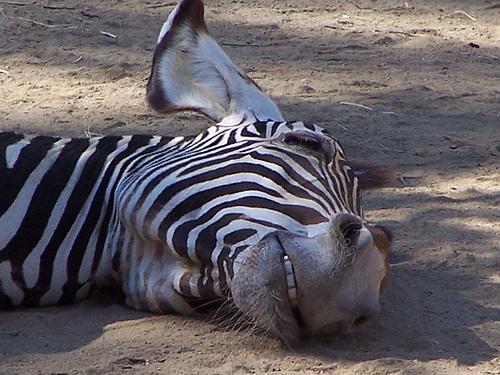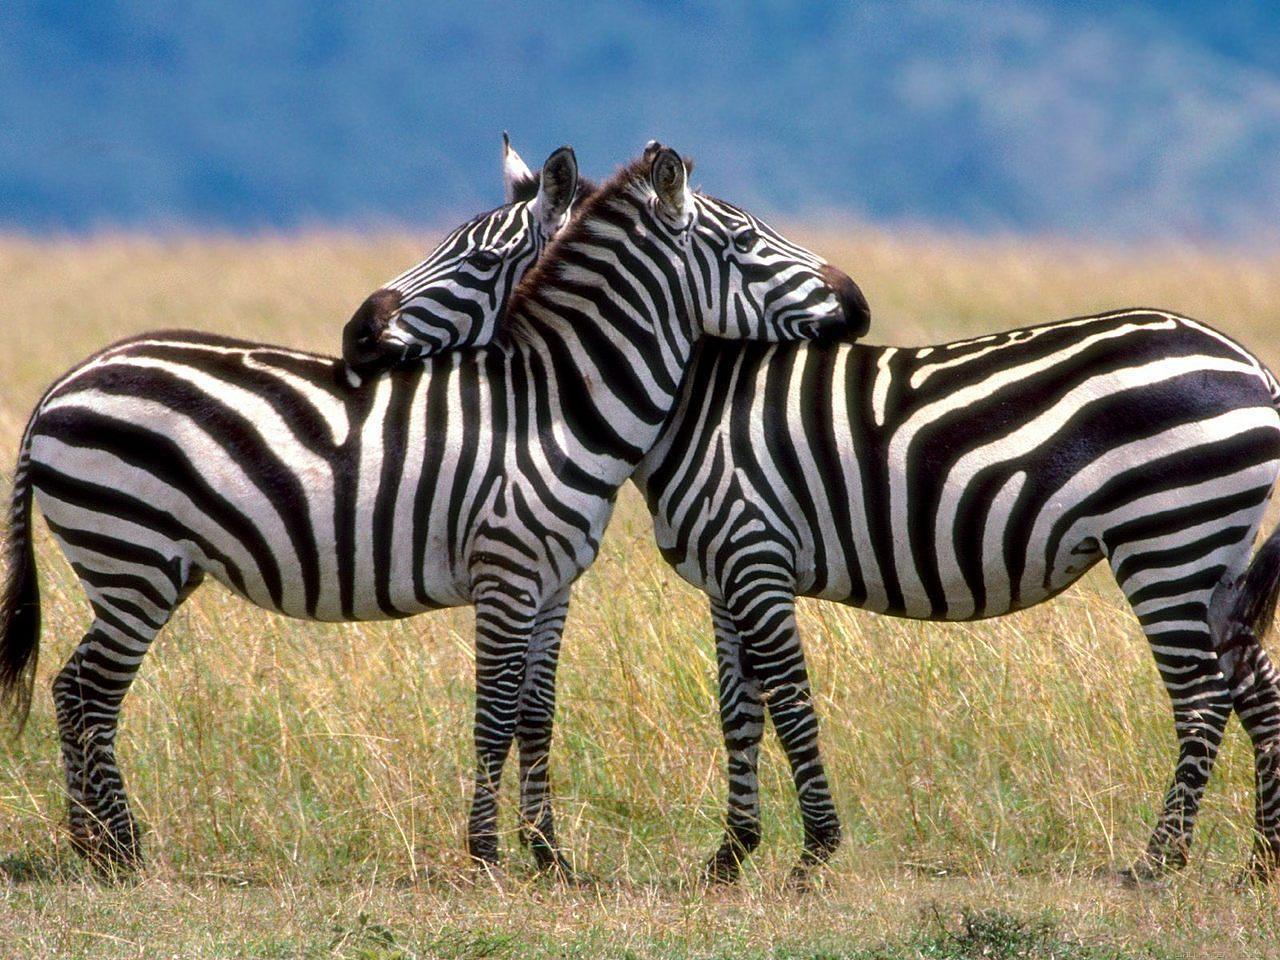The first image is the image on the left, the second image is the image on the right. Examine the images to the left and right. Is the description "One of the images features a single zebra laying completely sideways on the ground." accurate? Answer yes or no. Yes. The first image is the image on the left, the second image is the image on the right. For the images displayed, is the sentence "One image includes a zebra lying completely flat on the ground, and the othe image includes a zebra with its head lifted, mouth open and teeth showing in a braying pose." factually correct? Answer yes or no. No. 